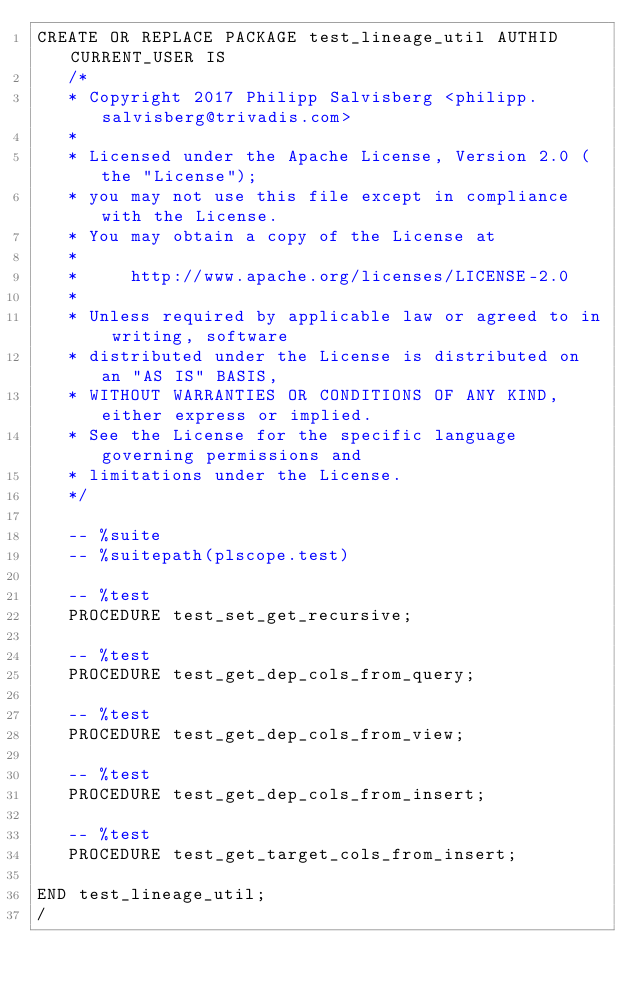<code> <loc_0><loc_0><loc_500><loc_500><_SQL_>CREATE OR REPLACE PACKAGE test_lineage_util AUTHID CURRENT_USER IS
   /*
   * Copyright 2017 Philipp Salvisberg <philipp.salvisberg@trivadis.com>
   *
   * Licensed under the Apache License, Version 2.0 (the "License");
   * you may not use this file except in compliance with the License.
   * You may obtain a copy of the License at
   *
   *     http://www.apache.org/licenses/LICENSE-2.0
   *
   * Unless required by applicable law or agreed to in writing, software
   * distributed under the License is distributed on an "AS IS" BASIS,
   * WITHOUT WARRANTIES OR CONDITIONS OF ANY KIND, either express or implied.
   * See the License for the specific language governing permissions and
   * limitations under the License.
   */
   
   -- %suite
   -- %suitepath(plscope.test)
   
   -- %test
   PROCEDURE test_set_get_recursive;

   -- %test
   PROCEDURE test_get_dep_cols_from_query;

   -- %test
   PROCEDURE test_get_dep_cols_from_view;
   
   -- %test
   PROCEDURE test_get_dep_cols_from_insert;

   -- %test
   PROCEDURE test_get_target_cols_from_insert;
   
END test_lineage_util;
/
</code> 